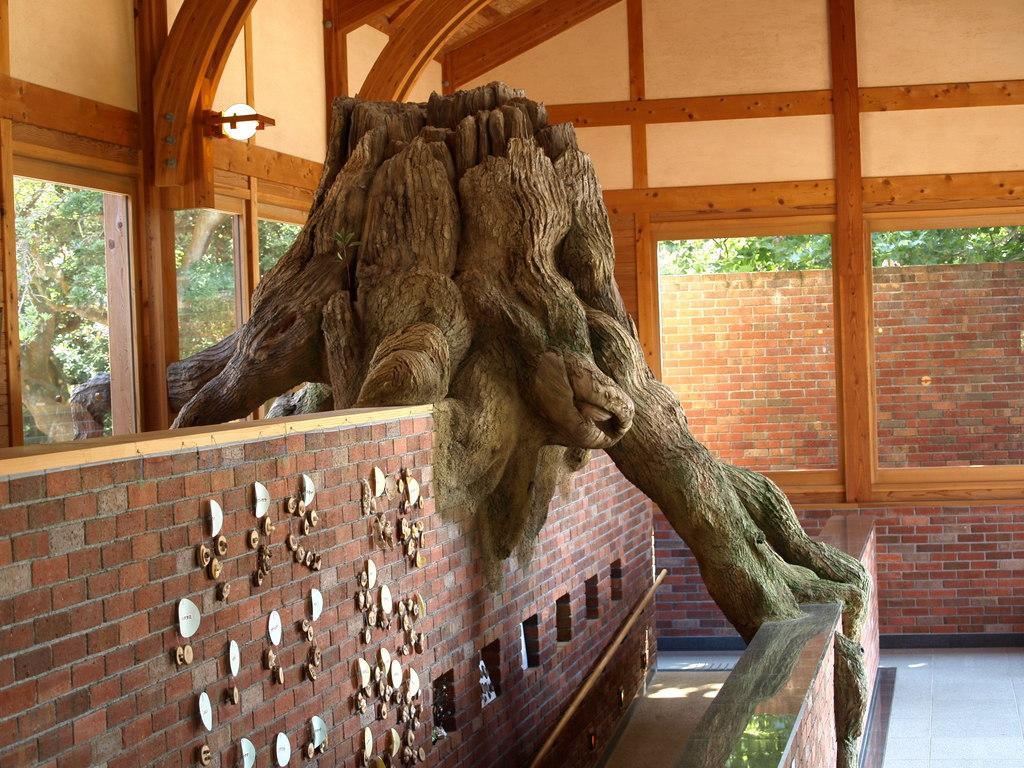Could you give a brief overview of what you see in this image? In this image we can see some brick walls, tree trunk, windows and behind the windows we can see some trees. 